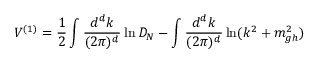Convert formula to latex. <formula><loc_0><loc_0><loc_500><loc_500>V ^ { ( 1 ) } = \frac { 1 } { 2 } \int \frac { d ^ { d } k } { ( 2 \pi ) ^ { d } } \ln D _ { N } - \int \frac { d ^ { d } k } { ( 2 \pi ) ^ { d } } \ln ( k ^ { 2 } + m _ { g h } ^ { 2 } )</formula> 